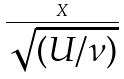<formula> <loc_0><loc_0><loc_500><loc_500>\frac { X } { \sqrt { ( U / \nu ) } }</formula> 